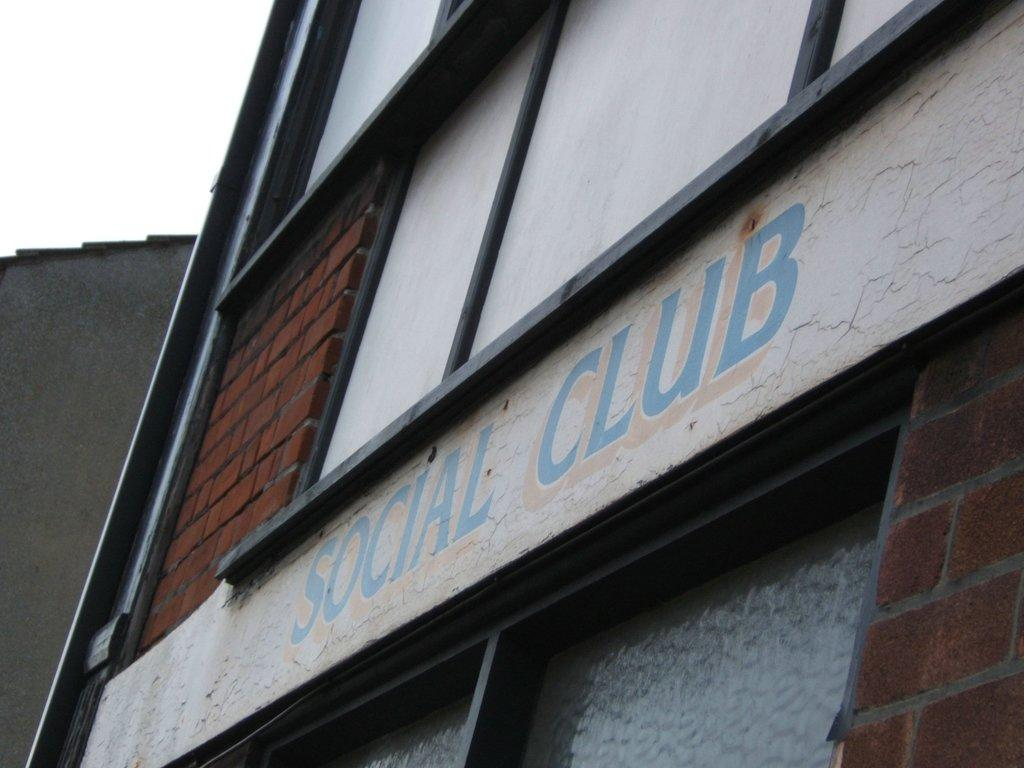What type of structure is present in the image? There is a building in the image. What else can be seen in the image besides the building? There is a wall in the image. What part of the natural environment is visible in the image? The sky is visible in the image. What word is written on the bed in the image? There is no bed present in the image, so it is not possible to answer that question. 